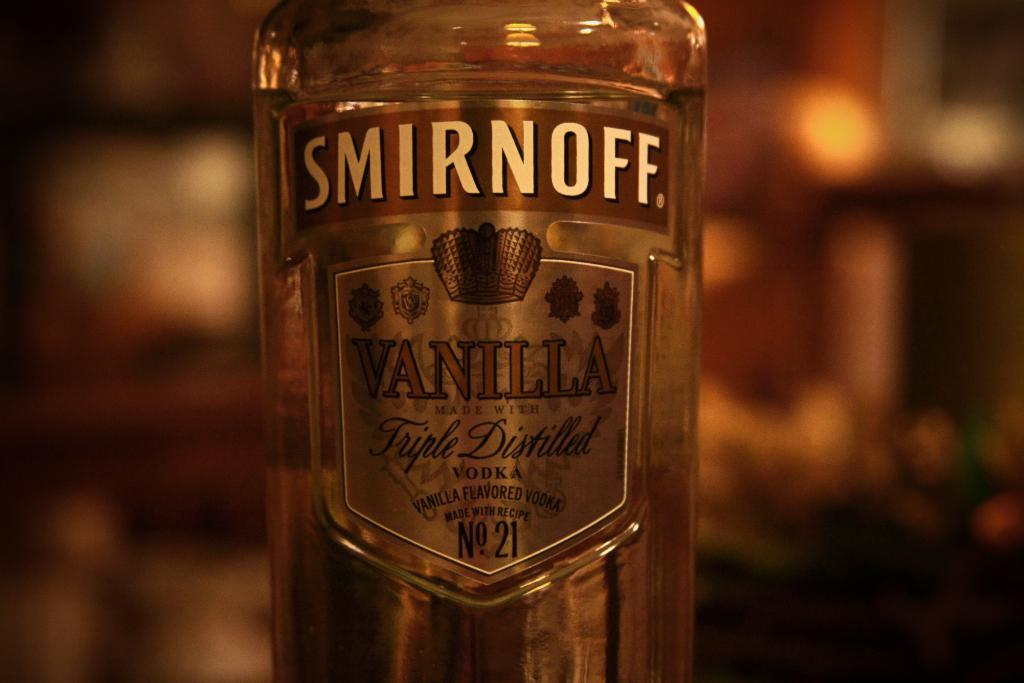What flavor is this alcohol?
Make the answer very short. Vanilla. 